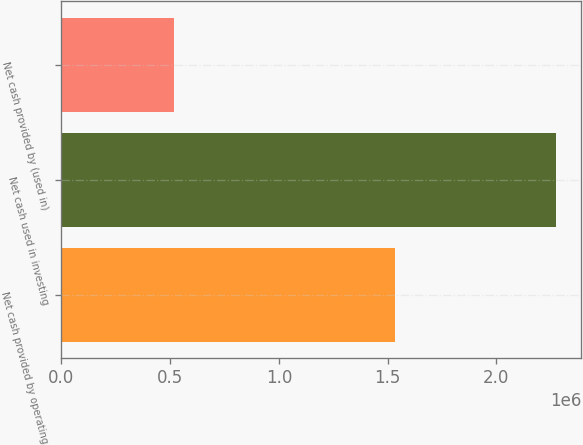Convert chart. <chart><loc_0><loc_0><loc_500><loc_500><bar_chart><fcel>Net cash provided by operating<fcel>Net cash used in investing<fcel>Net cash provided by (used in)<nl><fcel>1.53397e+06<fcel>2.2762e+06<fcel>519422<nl></chart> 